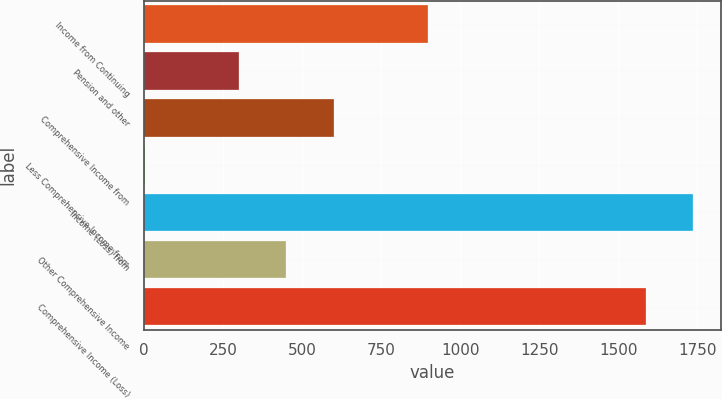<chart> <loc_0><loc_0><loc_500><loc_500><bar_chart><fcel>Income from Continuing<fcel>Pension and other<fcel>Comprehensive Income from<fcel>Less Comprehensive Income from<fcel>Income (Loss) from<fcel>Other Comprehensive Income<fcel>Comprehensive Income (Loss)<nl><fcel>898.4<fcel>300.8<fcel>599.6<fcel>2<fcel>1736.8<fcel>450.2<fcel>1587.4<nl></chart> 